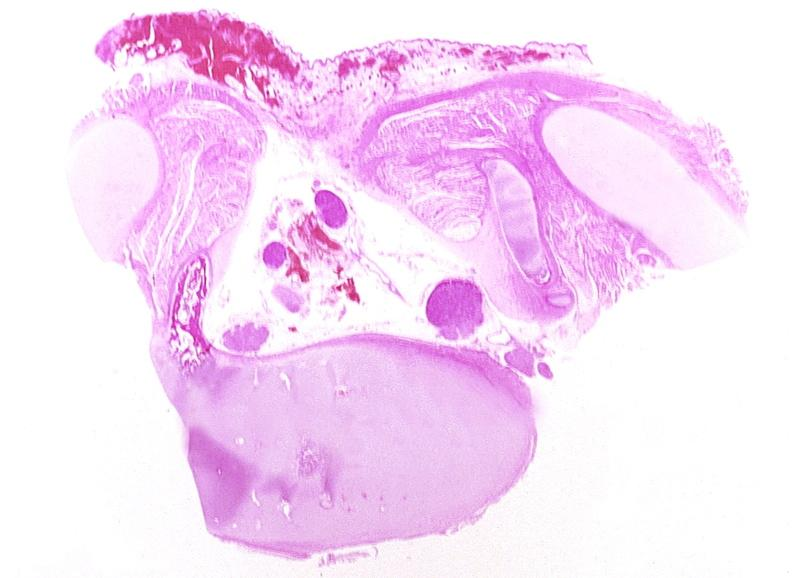s nervous present?
Answer the question using a single word or phrase. Yes 